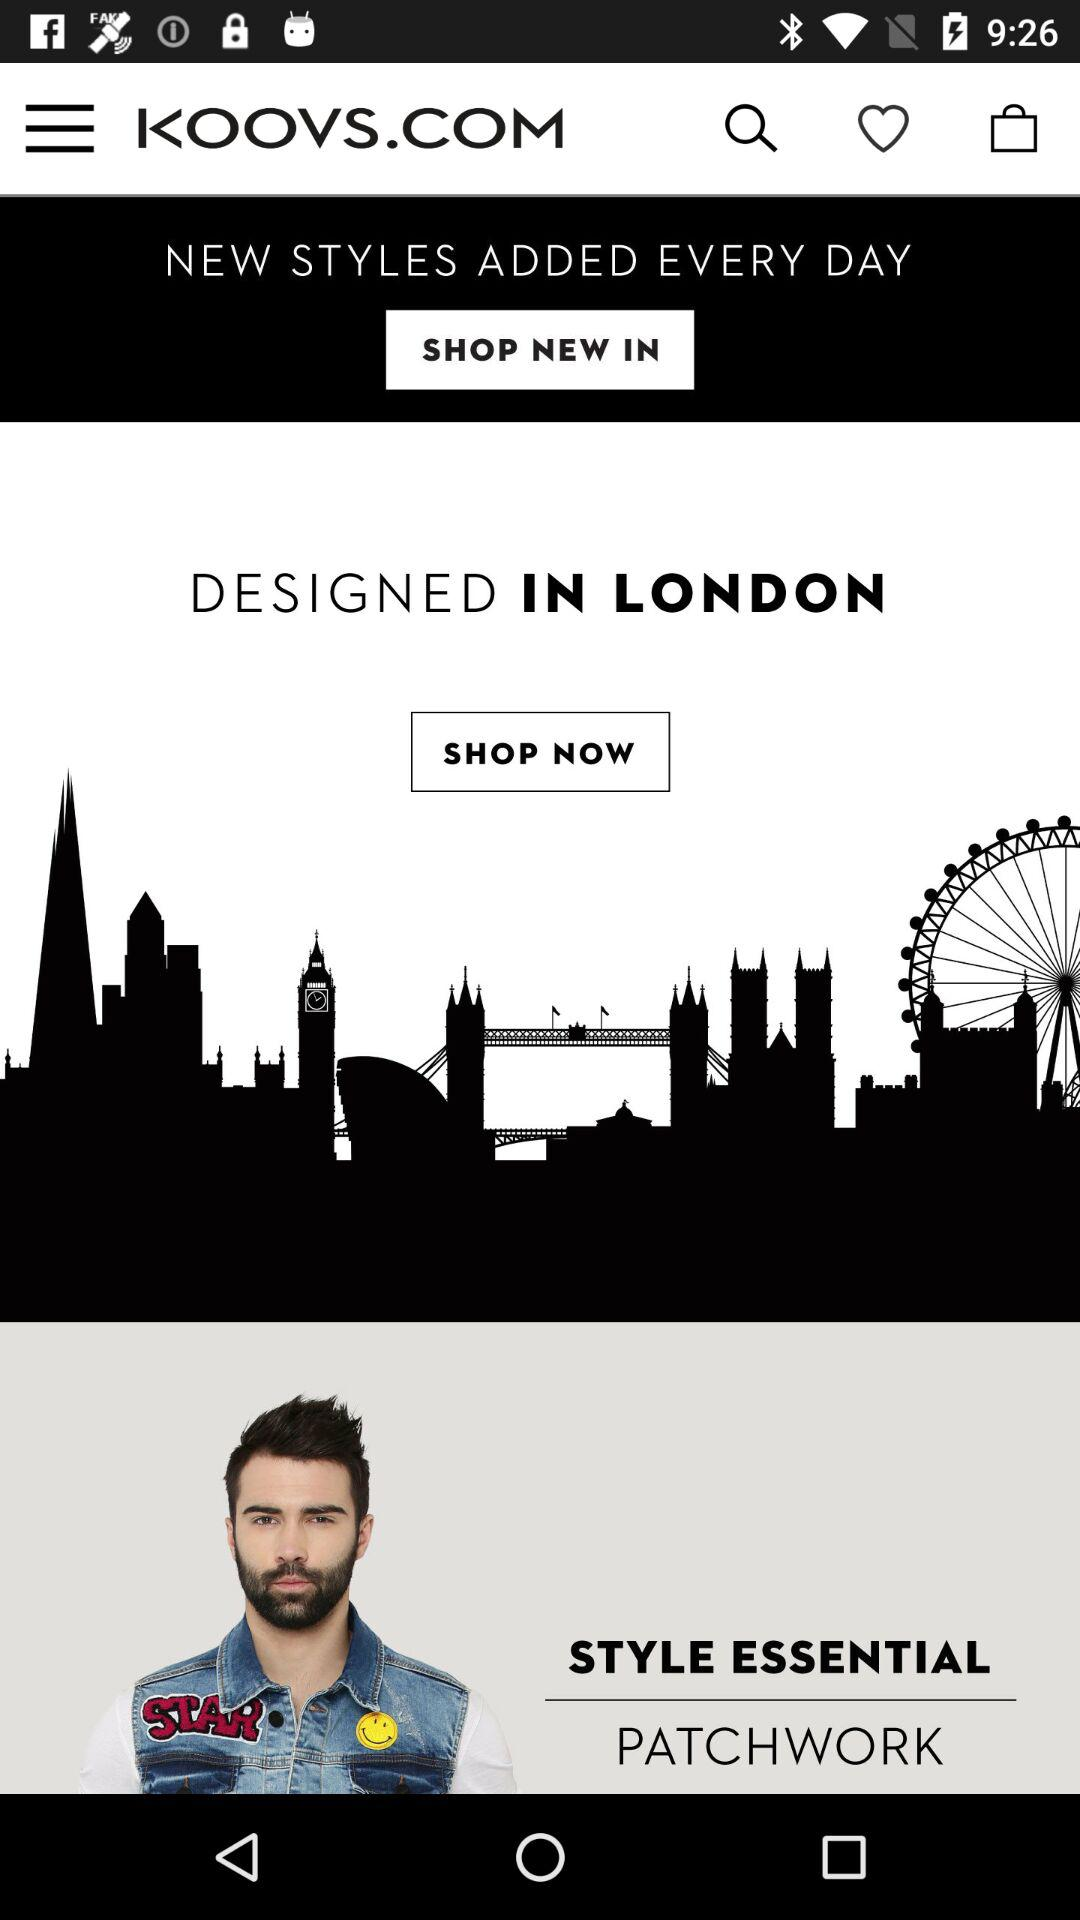Designed in which country?
When the provided information is insufficient, respond with <no answer>. <no answer> 